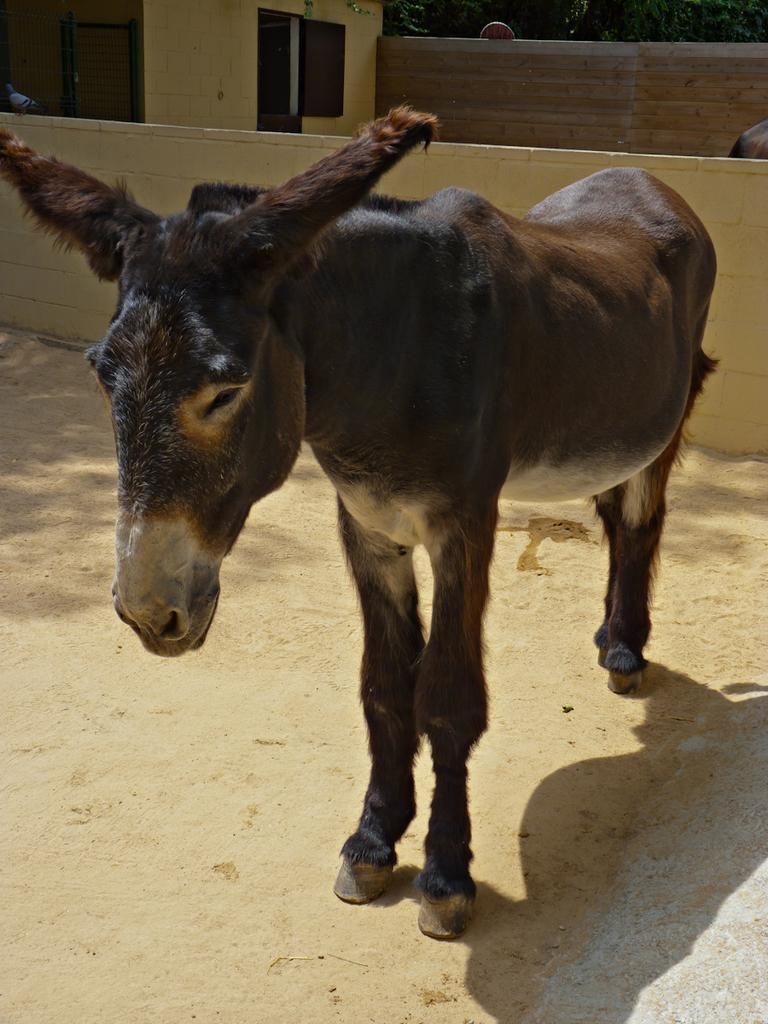What type of animal is standing in the image? There is a donkey standing in the image. What structures can be seen in the image? There are walls and a house in the image. What other living creature is present in the image? There is a bird in the image. Can you describe the background of the image? There are trees in the background of the image. What page of the history book is the donkey reading in the image? There is no history book or reading activity depicted in the image. 